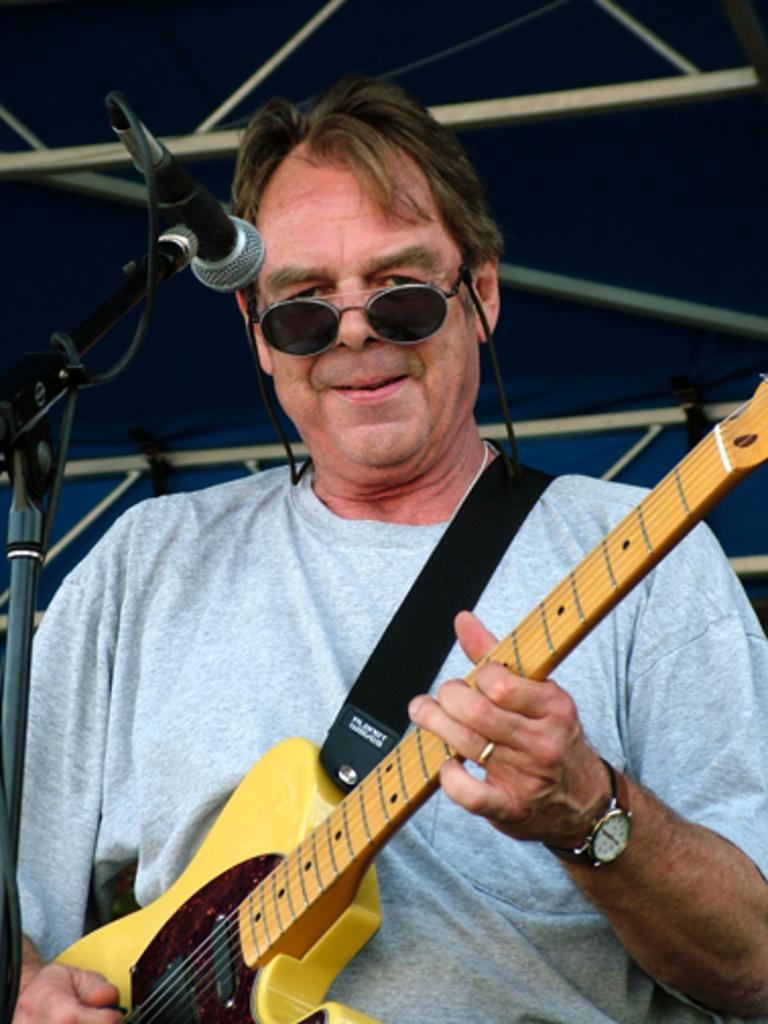Can you describe this image briefly? In this picture there is a man standing, he is holding the guitar with his left hand and playing the guitar with right hand. 